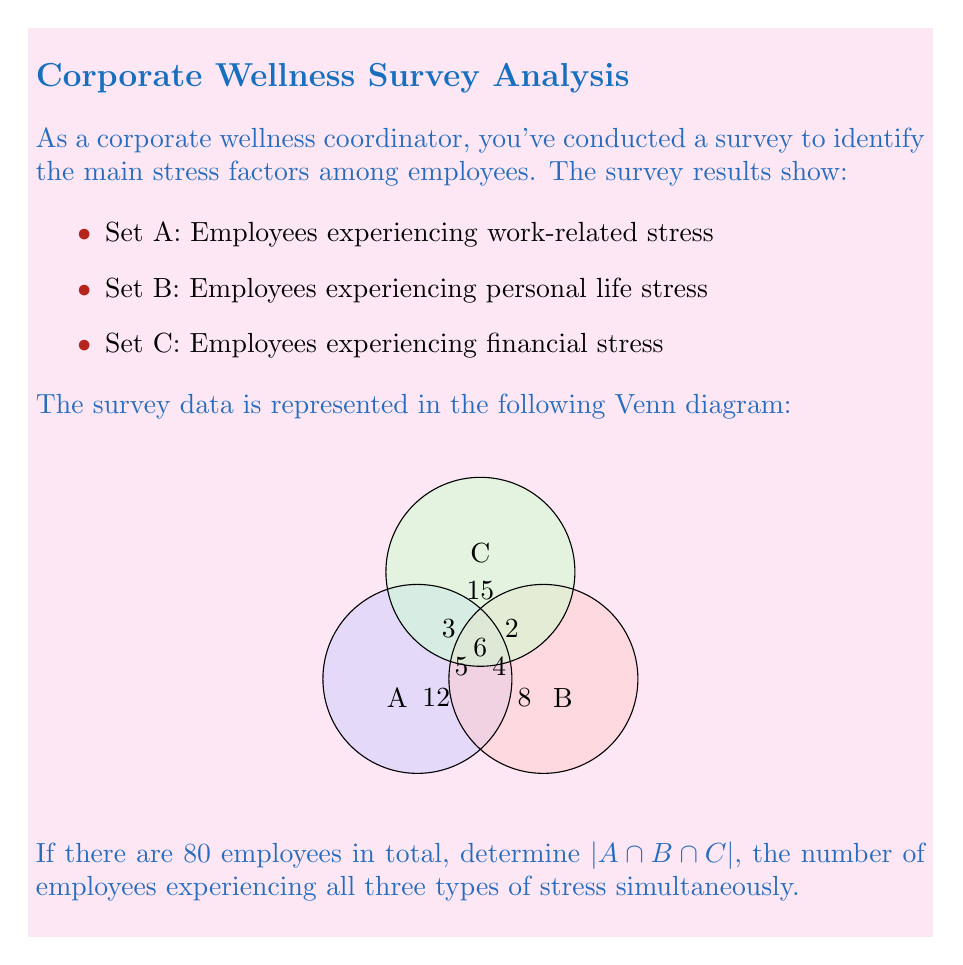Provide a solution to this math problem. Let's approach this step-by-step:

1) First, we need to understand what $|A \cap B \cap C|$ represents. It's the number of employees who are in all three sets simultaneously, which is represented by the central region where all three circles overlap.

2) To find this, we'll use the principle of inclusion-exclusion for three sets:

   $$|A \cup B \cup C| = |A| + |B| + |C| - |A \cap B| - |B \cap C| - |A \cap C| + |A \cap B \cap C|$$

3) We know the total number of employees is 80, so $|A \cup B \cup C| = 80$.

4) From the Venn diagram, we can calculate:
   - $|A| = 12 + 5 + 3 + 6 = 26$
   - $|B| = 8 + 4 + 2 + 6 = 20$
   - $|C| = 15 + 3 + 2 + 6 = 26$
   - $|A \cap B| = 6$
   - $|B \cap C| = 2$
   - $|A \cap C| = 3$

5) Now, let's substitute these values into our equation:

   $$80 = 26 + 20 + 26 - 6 - 2 - 3 + |A \cap B \cap C|$$

6) Simplify:
   $$80 = 61 + |A \cap B \cap C|$$

7) Solve for $|A \cap B \cap C|$:
   $$|A \cap B \cap C| = 80 - 61 = 19$$

Therefore, 19 employees are experiencing all three types of stress simultaneously.
Answer: 19 